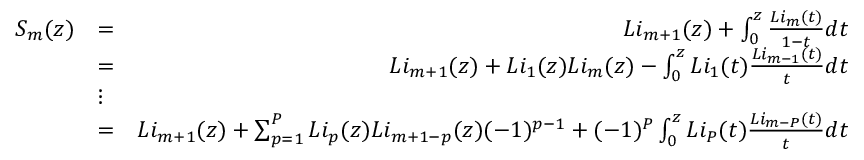Convert formula to latex. <formula><loc_0><loc_0><loc_500><loc_500>\begin{array} { r l r } { S _ { m } ( z ) } & { = } & { L i _ { m + 1 } ( z ) + \int _ { 0 } ^ { z } \frac { L i _ { m } ( t ) } { 1 - t } d t } \\ & { = } & { L i _ { m + 1 } ( z ) + L i _ { 1 } ( z ) L i _ { m } ( z ) - \int _ { 0 } ^ { z } L i _ { 1 } ( t ) \frac { L i _ { m - 1 } ( t ) } { t } d t } \\ & { \vdots } & \\ & { = } & { L i _ { m + 1 } ( z ) + \sum _ { p = 1 } ^ { P } L i _ { p } ( z ) L i _ { m + 1 - p } ( z ) ( - 1 ) ^ { p - 1 } + ( - 1 ) ^ { P } \int _ { 0 } ^ { z } L i _ { P } ( t ) \frac { L i _ { m - P } ( t ) } { t } d t } \end{array}</formula> 